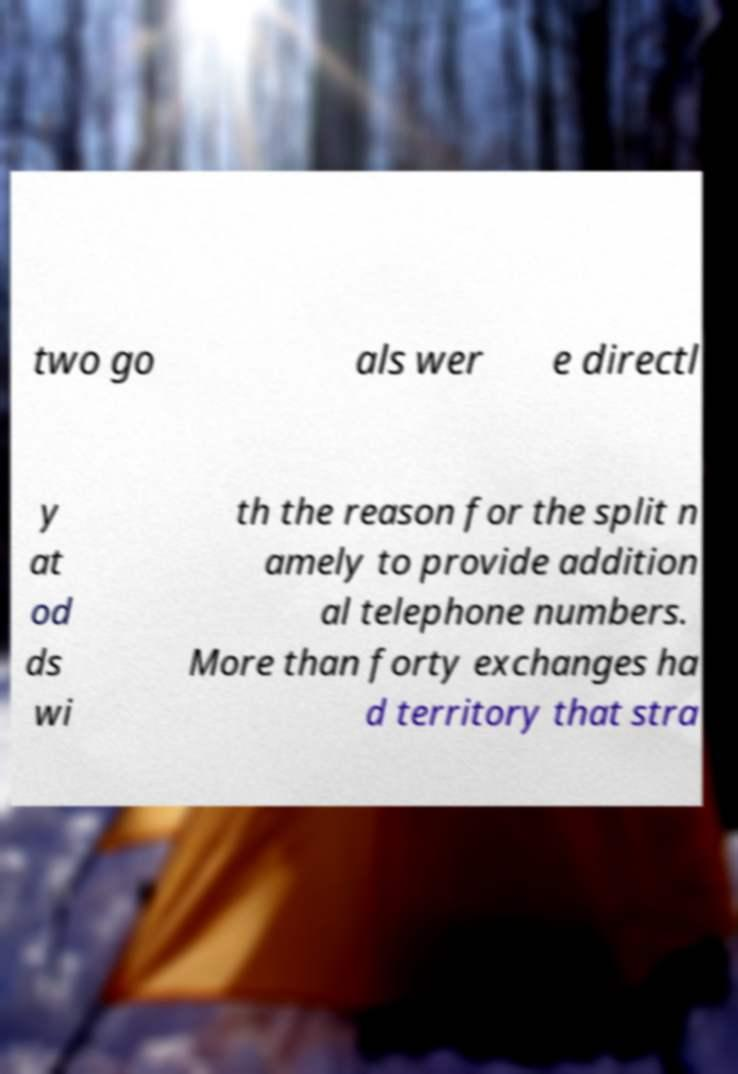Can you accurately transcribe the text from the provided image for me? two go als wer e directl y at od ds wi th the reason for the split n amely to provide addition al telephone numbers. More than forty exchanges ha d territory that stra 